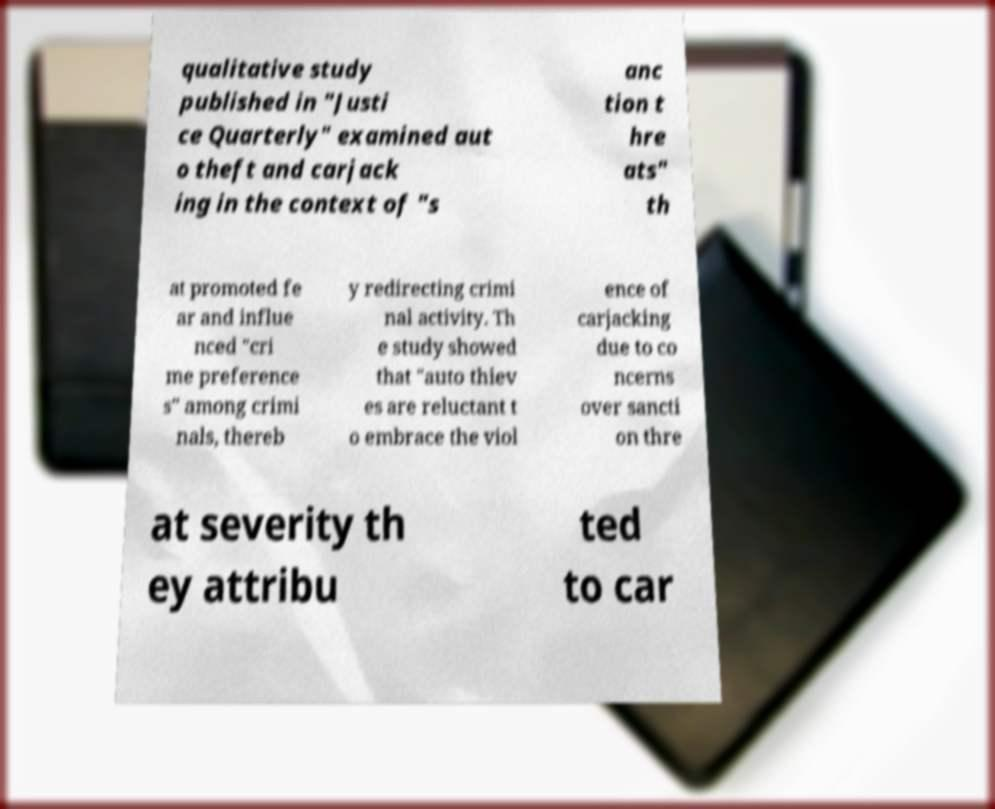Please read and relay the text visible in this image. What does it say? qualitative study published in "Justi ce Quarterly" examined aut o theft and carjack ing in the context of "s anc tion t hre ats" th at promoted fe ar and influe nced "cri me preference s" among crimi nals, thereb y redirecting crimi nal activity. Th e study showed that "auto thiev es are reluctant t o embrace the viol ence of carjacking due to co ncerns over sancti on thre at severity th ey attribu ted to car 